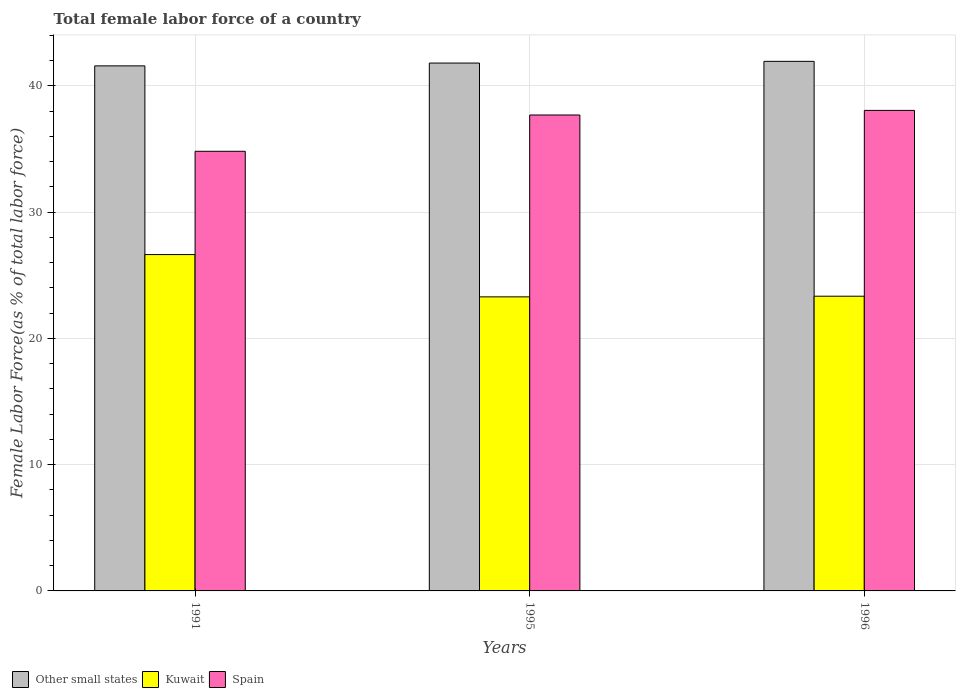How many different coloured bars are there?
Keep it short and to the point. 3. How many bars are there on the 2nd tick from the left?
Offer a terse response. 3. What is the percentage of female labor force in Kuwait in 1996?
Keep it short and to the point. 23.34. Across all years, what is the maximum percentage of female labor force in Spain?
Offer a terse response. 38.05. Across all years, what is the minimum percentage of female labor force in Other small states?
Offer a very short reply. 41.58. In which year was the percentage of female labor force in Other small states maximum?
Offer a terse response. 1996. What is the total percentage of female labor force in Spain in the graph?
Offer a terse response. 110.55. What is the difference between the percentage of female labor force in Other small states in 1991 and that in 1995?
Keep it short and to the point. -0.22. What is the difference between the percentage of female labor force in Spain in 1991 and the percentage of female labor force in Kuwait in 1996?
Your answer should be very brief. 11.48. What is the average percentage of female labor force in Spain per year?
Your answer should be very brief. 36.85. In the year 1991, what is the difference between the percentage of female labor force in Kuwait and percentage of female labor force in Other small states?
Ensure brevity in your answer.  -14.94. What is the ratio of the percentage of female labor force in Other small states in 1991 to that in 1995?
Your response must be concise. 0.99. What is the difference between the highest and the second highest percentage of female labor force in Other small states?
Keep it short and to the point. 0.14. What is the difference between the highest and the lowest percentage of female labor force in Spain?
Offer a very short reply. 3.24. In how many years, is the percentage of female labor force in Spain greater than the average percentage of female labor force in Spain taken over all years?
Your response must be concise. 2. What does the 2nd bar from the left in 1996 represents?
Make the answer very short. Kuwait. What does the 1st bar from the right in 1991 represents?
Ensure brevity in your answer.  Spain. Is it the case that in every year, the sum of the percentage of female labor force in Kuwait and percentage of female labor force in Spain is greater than the percentage of female labor force in Other small states?
Give a very brief answer. Yes. How many bars are there?
Offer a terse response. 9. What is the difference between two consecutive major ticks on the Y-axis?
Give a very brief answer. 10. Are the values on the major ticks of Y-axis written in scientific E-notation?
Keep it short and to the point. No. Does the graph contain any zero values?
Your response must be concise. No. Does the graph contain grids?
Offer a very short reply. Yes. Where does the legend appear in the graph?
Ensure brevity in your answer.  Bottom left. What is the title of the graph?
Provide a succinct answer. Total female labor force of a country. Does "Morocco" appear as one of the legend labels in the graph?
Keep it short and to the point. No. What is the label or title of the Y-axis?
Ensure brevity in your answer.  Female Labor Force(as % of total labor force). What is the Female Labor Force(as % of total labor force) of Other small states in 1991?
Offer a very short reply. 41.58. What is the Female Labor Force(as % of total labor force) of Kuwait in 1991?
Make the answer very short. 26.63. What is the Female Labor Force(as % of total labor force) of Spain in 1991?
Offer a very short reply. 34.81. What is the Female Labor Force(as % of total labor force) in Other small states in 1995?
Offer a very short reply. 41.8. What is the Female Labor Force(as % of total labor force) in Kuwait in 1995?
Keep it short and to the point. 23.28. What is the Female Labor Force(as % of total labor force) in Spain in 1995?
Provide a short and direct response. 37.69. What is the Female Labor Force(as % of total labor force) of Other small states in 1996?
Ensure brevity in your answer.  41.93. What is the Female Labor Force(as % of total labor force) in Kuwait in 1996?
Ensure brevity in your answer.  23.34. What is the Female Labor Force(as % of total labor force) in Spain in 1996?
Provide a short and direct response. 38.05. Across all years, what is the maximum Female Labor Force(as % of total labor force) of Other small states?
Provide a short and direct response. 41.93. Across all years, what is the maximum Female Labor Force(as % of total labor force) in Kuwait?
Provide a succinct answer. 26.63. Across all years, what is the maximum Female Labor Force(as % of total labor force) in Spain?
Offer a terse response. 38.05. Across all years, what is the minimum Female Labor Force(as % of total labor force) of Other small states?
Offer a terse response. 41.58. Across all years, what is the minimum Female Labor Force(as % of total labor force) of Kuwait?
Provide a succinct answer. 23.28. Across all years, what is the minimum Female Labor Force(as % of total labor force) in Spain?
Provide a short and direct response. 34.81. What is the total Female Labor Force(as % of total labor force) of Other small states in the graph?
Offer a very short reply. 125.31. What is the total Female Labor Force(as % of total labor force) of Kuwait in the graph?
Your response must be concise. 73.25. What is the total Female Labor Force(as % of total labor force) of Spain in the graph?
Ensure brevity in your answer.  110.55. What is the difference between the Female Labor Force(as % of total labor force) of Other small states in 1991 and that in 1995?
Make the answer very short. -0.22. What is the difference between the Female Labor Force(as % of total labor force) of Kuwait in 1991 and that in 1995?
Your answer should be compact. 3.35. What is the difference between the Female Labor Force(as % of total labor force) of Spain in 1991 and that in 1995?
Your answer should be very brief. -2.87. What is the difference between the Female Labor Force(as % of total labor force) in Other small states in 1991 and that in 1996?
Make the answer very short. -0.36. What is the difference between the Female Labor Force(as % of total labor force) of Kuwait in 1991 and that in 1996?
Your response must be concise. 3.3. What is the difference between the Female Labor Force(as % of total labor force) in Spain in 1991 and that in 1996?
Your response must be concise. -3.24. What is the difference between the Female Labor Force(as % of total labor force) of Other small states in 1995 and that in 1996?
Your response must be concise. -0.14. What is the difference between the Female Labor Force(as % of total labor force) of Kuwait in 1995 and that in 1996?
Offer a terse response. -0.05. What is the difference between the Female Labor Force(as % of total labor force) in Spain in 1995 and that in 1996?
Your answer should be compact. -0.36. What is the difference between the Female Labor Force(as % of total labor force) of Other small states in 1991 and the Female Labor Force(as % of total labor force) of Kuwait in 1995?
Make the answer very short. 18.29. What is the difference between the Female Labor Force(as % of total labor force) in Other small states in 1991 and the Female Labor Force(as % of total labor force) in Spain in 1995?
Provide a succinct answer. 3.89. What is the difference between the Female Labor Force(as % of total labor force) in Kuwait in 1991 and the Female Labor Force(as % of total labor force) in Spain in 1995?
Provide a succinct answer. -11.05. What is the difference between the Female Labor Force(as % of total labor force) in Other small states in 1991 and the Female Labor Force(as % of total labor force) in Kuwait in 1996?
Your answer should be compact. 18.24. What is the difference between the Female Labor Force(as % of total labor force) of Other small states in 1991 and the Female Labor Force(as % of total labor force) of Spain in 1996?
Your answer should be compact. 3.53. What is the difference between the Female Labor Force(as % of total labor force) in Kuwait in 1991 and the Female Labor Force(as % of total labor force) in Spain in 1996?
Your answer should be very brief. -11.42. What is the difference between the Female Labor Force(as % of total labor force) of Other small states in 1995 and the Female Labor Force(as % of total labor force) of Kuwait in 1996?
Your answer should be compact. 18.46. What is the difference between the Female Labor Force(as % of total labor force) in Other small states in 1995 and the Female Labor Force(as % of total labor force) in Spain in 1996?
Provide a short and direct response. 3.75. What is the difference between the Female Labor Force(as % of total labor force) of Kuwait in 1995 and the Female Labor Force(as % of total labor force) of Spain in 1996?
Offer a terse response. -14.77. What is the average Female Labor Force(as % of total labor force) of Other small states per year?
Make the answer very short. 41.77. What is the average Female Labor Force(as % of total labor force) of Kuwait per year?
Make the answer very short. 24.42. What is the average Female Labor Force(as % of total labor force) in Spain per year?
Offer a very short reply. 36.85. In the year 1991, what is the difference between the Female Labor Force(as % of total labor force) in Other small states and Female Labor Force(as % of total labor force) in Kuwait?
Provide a short and direct response. 14.94. In the year 1991, what is the difference between the Female Labor Force(as % of total labor force) in Other small states and Female Labor Force(as % of total labor force) in Spain?
Make the answer very short. 6.76. In the year 1991, what is the difference between the Female Labor Force(as % of total labor force) of Kuwait and Female Labor Force(as % of total labor force) of Spain?
Provide a short and direct response. -8.18. In the year 1995, what is the difference between the Female Labor Force(as % of total labor force) in Other small states and Female Labor Force(as % of total labor force) in Kuwait?
Give a very brief answer. 18.51. In the year 1995, what is the difference between the Female Labor Force(as % of total labor force) in Other small states and Female Labor Force(as % of total labor force) in Spain?
Make the answer very short. 4.11. In the year 1995, what is the difference between the Female Labor Force(as % of total labor force) of Kuwait and Female Labor Force(as % of total labor force) of Spain?
Your answer should be very brief. -14.4. In the year 1996, what is the difference between the Female Labor Force(as % of total labor force) of Other small states and Female Labor Force(as % of total labor force) of Kuwait?
Your response must be concise. 18.6. In the year 1996, what is the difference between the Female Labor Force(as % of total labor force) in Other small states and Female Labor Force(as % of total labor force) in Spain?
Keep it short and to the point. 3.88. In the year 1996, what is the difference between the Female Labor Force(as % of total labor force) of Kuwait and Female Labor Force(as % of total labor force) of Spain?
Make the answer very short. -14.71. What is the ratio of the Female Labor Force(as % of total labor force) in Other small states in 1991 to that in 1995?
Ensure brevity in your answer.  0.99. What is the ratio of the Female Labor Force(as % of total labor force) in Kuwait in 1991 to that in 1995?
Provide a short and direct response. 1.14. What is the ratio of the Female Labor Force(as % of total labor force) in Spain in 1991 to that in 1995?
Ensure brevity in your answer.  0.92. What is the ratio of the Female Labor Force(as % of total labor force) in Kuwait in 1991 to that in 1996?
Keep it short and to the point. 1.14. What is the ratio of the Female Labor Force(as % of total labor force) of Spain in 1991 to that in 1996?
Keep it short and to the point. 0.91. What is the ratio of the Female Labor Force(as % of total labor force) of Other small states in 1995 to that in 1996?
Your response must be concise. 1. What is the difference between the highest and the second highest Female Labor Force(as % of total labor force) in Other small states?
Keep it short and to the point. 0.14. What is the difference between the highest and the second highest Female Labor Force(as % of total labor force) of Kuwait?
Make the answer very short. 3.3. What is the difference between the highest and the second highest Female Labor Force(as % of total labor force) in Spain?
Ensure brevity in your answer.  0.36. What is the difference between the highest and the lowest Female Labor Force(as % of total labor force) of Other small states?
Your response must be concise. 0.36. What is the difference between the highest and the lowest Female Labor Force(as % of total labor force) of Kuwait?
Ensure brevity in your answer.  3.35. What is the difference between the highest and the lowest Female Labor Force(as % of total labor force) of Spain?
Ensure brevity in your answer.  3.24. 